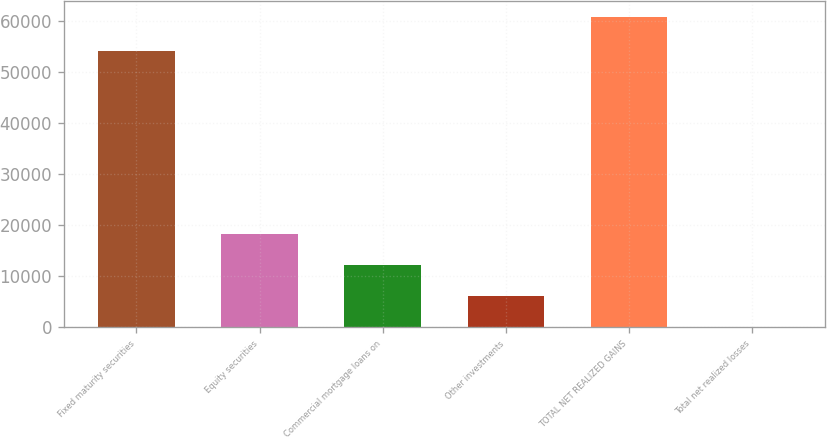Convert chart to OTSL. <chart><loc_0><loc_0><loc_500><loc_500><bar_chart><fcel>Fixed maturity securities<fcel>Equity securities<fcel>Commercial mortgage loans on<fcel>Other investments<fcel>TOTAL NET REALIZED GAINS<fcel>Total net realized losses<nl><fcel>54200<fcel>18264.9<fcel>12186.6<fcel>6108.3<fcel>60783<fcel>30<nl></chart> 